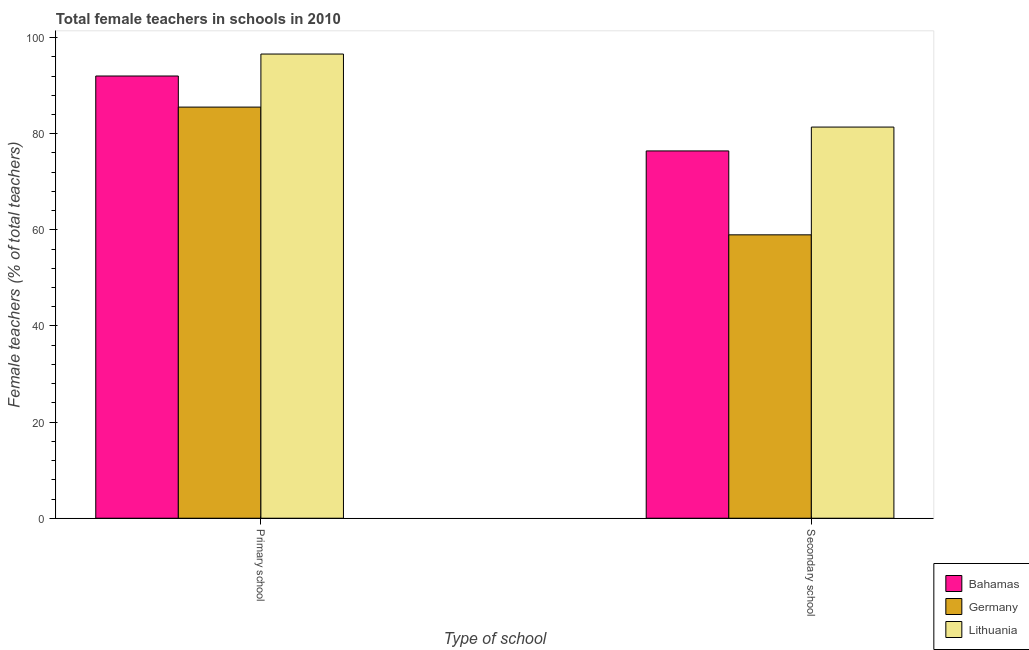Are the number of bars on each tick of the X-axis equal?
Your answer should be compact. Yes. How many bars are there on the 2nd tick from the left?
Give a very brief answer. 3. What is the label of the 2nd group of bars from the left?
Provide a short and direct response. Secondary school. What is the percentage of female teachers in secondary schools in Bahamas?
Your answer should be very brief. 76.42. Across all countries, what is the maximum percentage of female teachers in secondary schools?
Offer a very short reply. 81.38. Across all countries, what is the minimum percentage of female teachers in secondary schools?
Make the answer very short. 58.96. In which country was the percentage of female teachers in secondary schools maximum?
Your answer should be very brief. Lithuania. In which country was the percentage of female teachers in primary schools minimum?
Your answer should be very brief. Germany. What is the total percentage of female teachers in primary schools in the graph?
Your answer should be very brief. 274.12. What is the difference between the percentage of female teachers in primary schools in Germany and that in Bahamas?
Your answer should be compact. -6.47. What is the difference between the percentage of female teachers in primary schools in Germany and the percentage of female teachers in secondary schools in Lithuania?
Make the answer very short. 4.15. What is the average percentage of female teachers in secondary schools per country?
Provide a short and direct response. 72.26. What is the difference between the percentage of female teachers in secondary schools and percentage of female teachers in primary schools in Germany?
Make the answer very short. -26.58. In how many countries, is the percentage of female teachers in secondary schools greater than 72 %?
Your response must be concise. 2. What is the ratio of the percentage of female teachers in primary schools in Lithuania to that in Bahamas?
Your answer should be very brief. 1.05. In how many countries, is the percentage of female teachers in primary schools greater than the average percentage of female teachers in primary schools taken over all countries?
Your response must be concise. 2. What does the 3rd bar from the left in Primary school represents?
Provide a succinct answer. Lithuania. What does the 3rd bar from the right in Primary school represents?
Your answer should be compact. Bahamas. Are all the bars in the graph horizontal?
Your answer should be very brief. No. How many countries are there in the graph?
Your answer should be compact. 3. Are the values on the major ticks of Y-axis written in scientific E-notation?
Ensure brevity in your answer.  No. Does the graph contain any zero values?
Ensure brevity in your answer.  No. Does the graph contain grids?
Keep it short and to the point. No. Where does the legend appear in the graph?
Make the answer very short. Bottom right. How are the legend labels stacked?
Give a very brief answer. Vertical. What is the title of the graph?
Your response must be concise. Total female teachers in schools in 2010. What is the label or title of the X-axis?
Offer a very short reply. Type of school. What is the label or title of the Y-axis?
Provide a succinct answer. Female teachers (% of total teachers). What is the Female teachers (% of total teachers) in Bahamas in Primary school?
Offer a very short reply. 92.01. What is the Female teachers (% of total teachers) in Germany in Primary school?
Your answer should be very brief. 85.54. What is the Female teachers (% of total teachers) in Lithuania in Primary school?
Give a very brief answer. 96.58. What is the Female teachers (% of total teachers) of Bahamas in Secondary school?
Ensure brevity in your answer.  76.42. What is the Female teachers (% of total teachers) in Germany in Secondary school?
Offer a very short reply. 58.96. What is the Female teachers (% of total teachers) of Lithuania in Secondary school?
Give a very brief answer. 81.38. Across all Type of school, what is the maximum Female teachers (% of total teachers) in Bahamas?
Offer a terse response. 92.01. Across all Type of school, what is the maximum Female teachers (% of total teachers) of Germany?
Your answer should be compact. 85.54. Across all Type of school, what is the maximum Female teachers (% of total teachers) of Lithuania?
Your answer should be very brief. 96.58. Across all Type of school, what is the minimum Female teachers (% of total teachers) in Bahamas?
Make the answer very short. 76.42. Across all Type of school, what is the minimum Female teachers (% of total teachers) of Germany?
Offer a very short reply. 58.96. Across all Type of school, what is the minimum Female teachers (% of total teachers) in Lithuania?
Give a very brief answer. 81.38. What is the total Female teachers (% of total teachers) of Bahamas in the graph?
Offer a very short reply. 168.43. What is the total Female teachers (% of total teachers) in Germany in the graph?
Keep it short and to the point. 144.5. What is the total Female teachers (% of total teachers) in Lithuania in the graph?
Your answer should be compact. 177.96. What is the difference between the Female teachers (% of total teachers) of Bahamas in Primary school and that in Secondary school?
Make the answer very short. 15.59. What is the difference between the Female teachers (% of total teachers) in Germany in Primary school and that in Secondary school?
Your answer should be very brief. 26.58. What is the difference between the Female teachers (% of total teachers) in Lithuania in Primary school and that in Secondary school?
Provide a short and direct response. 15.2. What is the difference between the Female teachers (% of total teachers) in Bahamas in Primary school and the Female teachers (% of total teachers) in Germany in Secondary school?
Your answer should be very brief. 33.04. What is the difference between the Female teachers (% of total teachers) of Bahamas in Primary school and the Female teachers (% of total teachers) of Lithuania in Secondary school?
Your answer should be compact. 10.62. What is the difference between the Female teachers (% of total teachers) of Germany in Primary school and the Female teachers (% of total teachers) of Lithuania in Secondary school?
Ensure brevity in your answer.  4.15. What is the average Female teachers (% of total teachers) in Bahamas per Type of school?
Offer a very short reply. 84.21. What is the average Female teachers (% of total teachers) in Germany per Type of school?
Give a very brief answer. 72.25. What is the average Female teachers (% of total teachers) in Lithuania per Type of school?
Your answer should be compact. 88.98. What is the difference between the Female teachers (% of total teachers) in Bahamas and Female teachers (% of total teachers) in Germany in Primary school?
Offer a very short reply. 6.47. What is the difference between the Female teachers (% of total teachers) of Bahamas and Female teachers (% of total teachers) of Lithuania in Primary school?
Make the answer very short. -4.57. What is the difference between the Female teachers (% of total teachers) of Germany and Female teachers (% of total teachers) of Lithuania in Primary school?
Provide a succinct answer. -11.04. What is the difference between the Female teachers (% of total teachers) of Bahamas and Female teachers (% of total teachers) of Germany in Secondary school?
Provide a succinct answer. 17.46. What is the difference between the Female teachers (% of total teachers) of Bahamas and Female teachers (% of total teachers) of Lithuania in Secondary school?
Ensure brevity in your answer.  -4.97. What is the difference between the Female teachers (% of total teachers) in Germany and Female teachers (% of total teachers) in Lithuania in Secondary school?
Make the answer very short. -22.42. What is the ratio of the Female teachers (% of total teachers) of Bahamas in Primary school to that in Secondary school?
Give a very brief answer. 1.2. What is the ratio of the Female teachers (% of total teachers) in Germany in Primary school to that in Secondary school?
Make the answer very short. 1.45. What is the ratio of the Female teachers (% of total teachers) of Lithuania in Primary school to that in Secondary school?
Provide a succinct answer. 1.19. What is the difference between the highest and the second highest Female teachers (% of total teachers) of Bahamas?
Offer a very short reply. 15.59. What is the difference between the highest and the second highest Female teachers (% of total teachers) of Germany?
Your answer should be very brief. 26.58. What is the difference between the highest and the second highest Female teachers (% of total teachers) in Lithuania?
Make the answer very short. 15.2. What is the difference between the highest and the lowest Female teachers (% of total teachers) in Bahamas?
Offer a very short reply. 15.59. What is the difference between the highest and the lowest Female teachers (% of total teachers) of Germany?
Give a very brief answer. 26.58. What is the difference between the highest and the lowest Female teachers (% of total teachers) of Lithuania?
Offer a terse response. 15.2. 